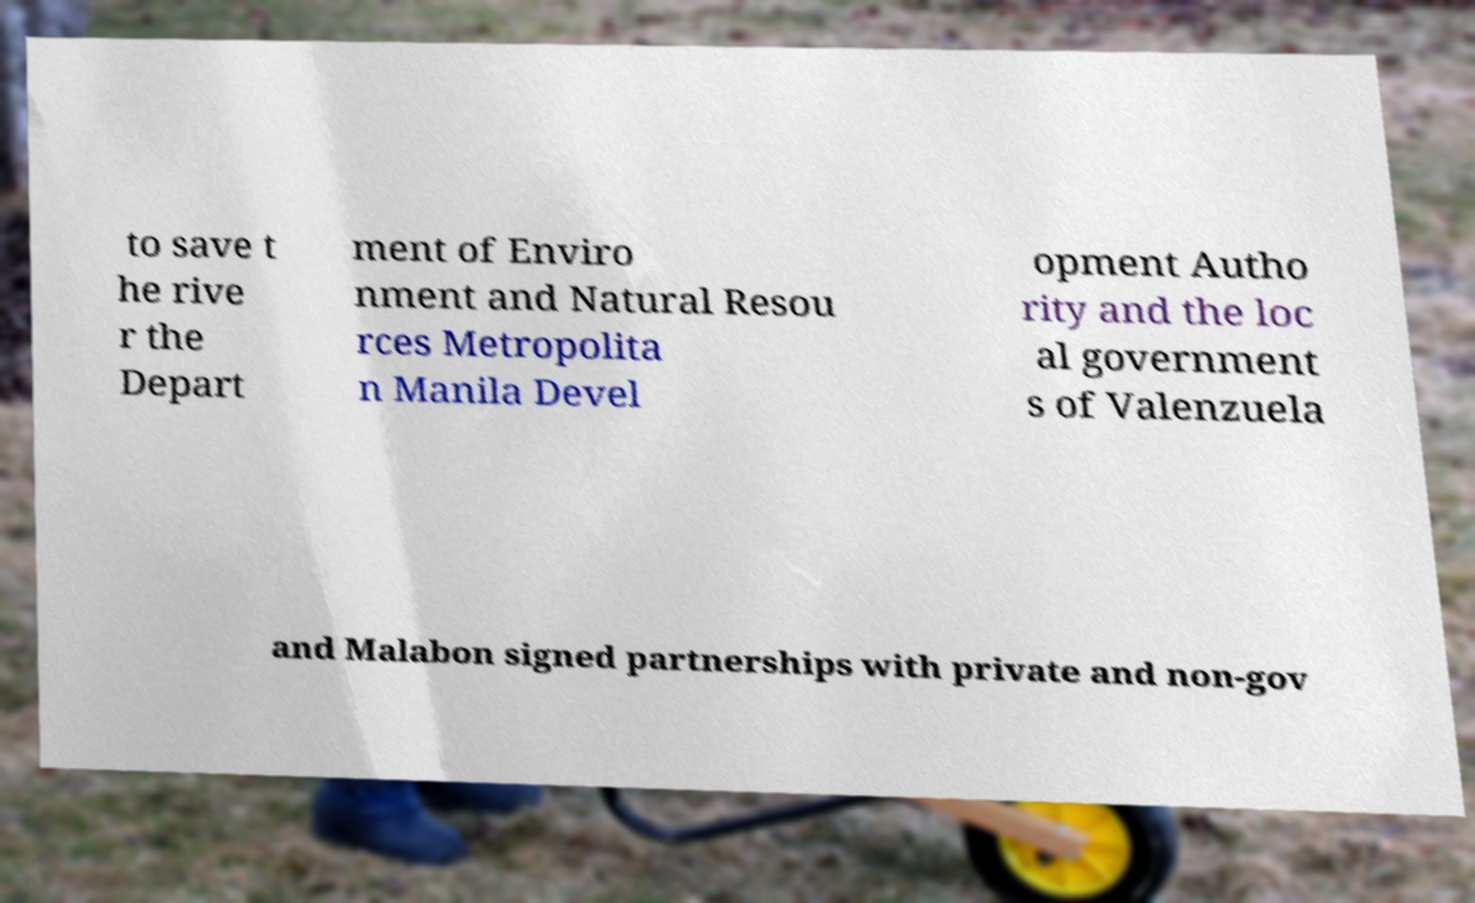Please read and relay the text visible in this image. What does it say? to save t he rive r the Depart ment of Enviro nment and Natural Resou rces Metropolita n Manila Devel opment Autho rity and the loc al government s of Valenzuela and Malabon signed partnerships with private and non-gov 